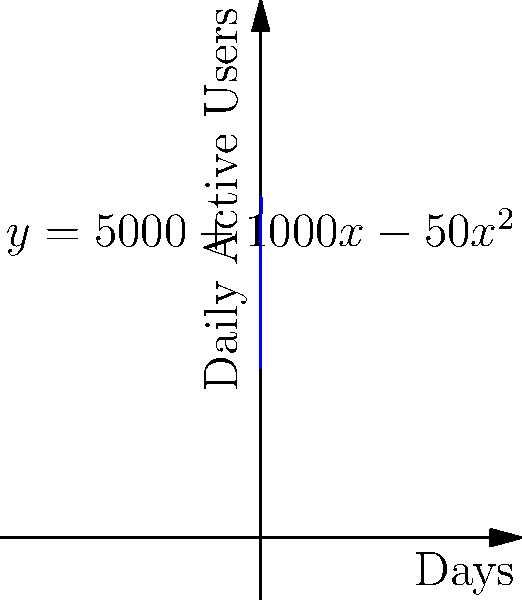A new social media platform's daily active users can be modeled by the function $f(x)=5000+1000x-50x^2$, where $x$ represents the number of days since launch and $f(x)$ represents the number of daily active users. Calculate the total number of user-days (cumulative daily active users) over the first 10 days after launch. To find the total number of user-days over the first 10 days, we need to calculate the area under the curve from $x=0$ to $x=10$. This can be done using definite integration:

1) The integral we need to evaluate is:
   $$\int_0^{10} (5000+1000x-50x^2) dx$$

2) Integrate each term:
   $$\left[5000x + 500x^2 - \frac{50}{3}x^3\right]_0^{10}$$

3) Evaluate at the upper and lower bounds:
   $$\left(50000 + 50000 - \frac{50000}{3}\right) - \left(0 + 0 - 0\right)$$

4) Simplify:
   $$100000 - \frac{50000}{3} = 100000 - 16666.67 = 83333.33$$

Therefore, the total number of user-days over the first 10 days is approximately 83,333 user-days.
Answer: 83,333 user-days 